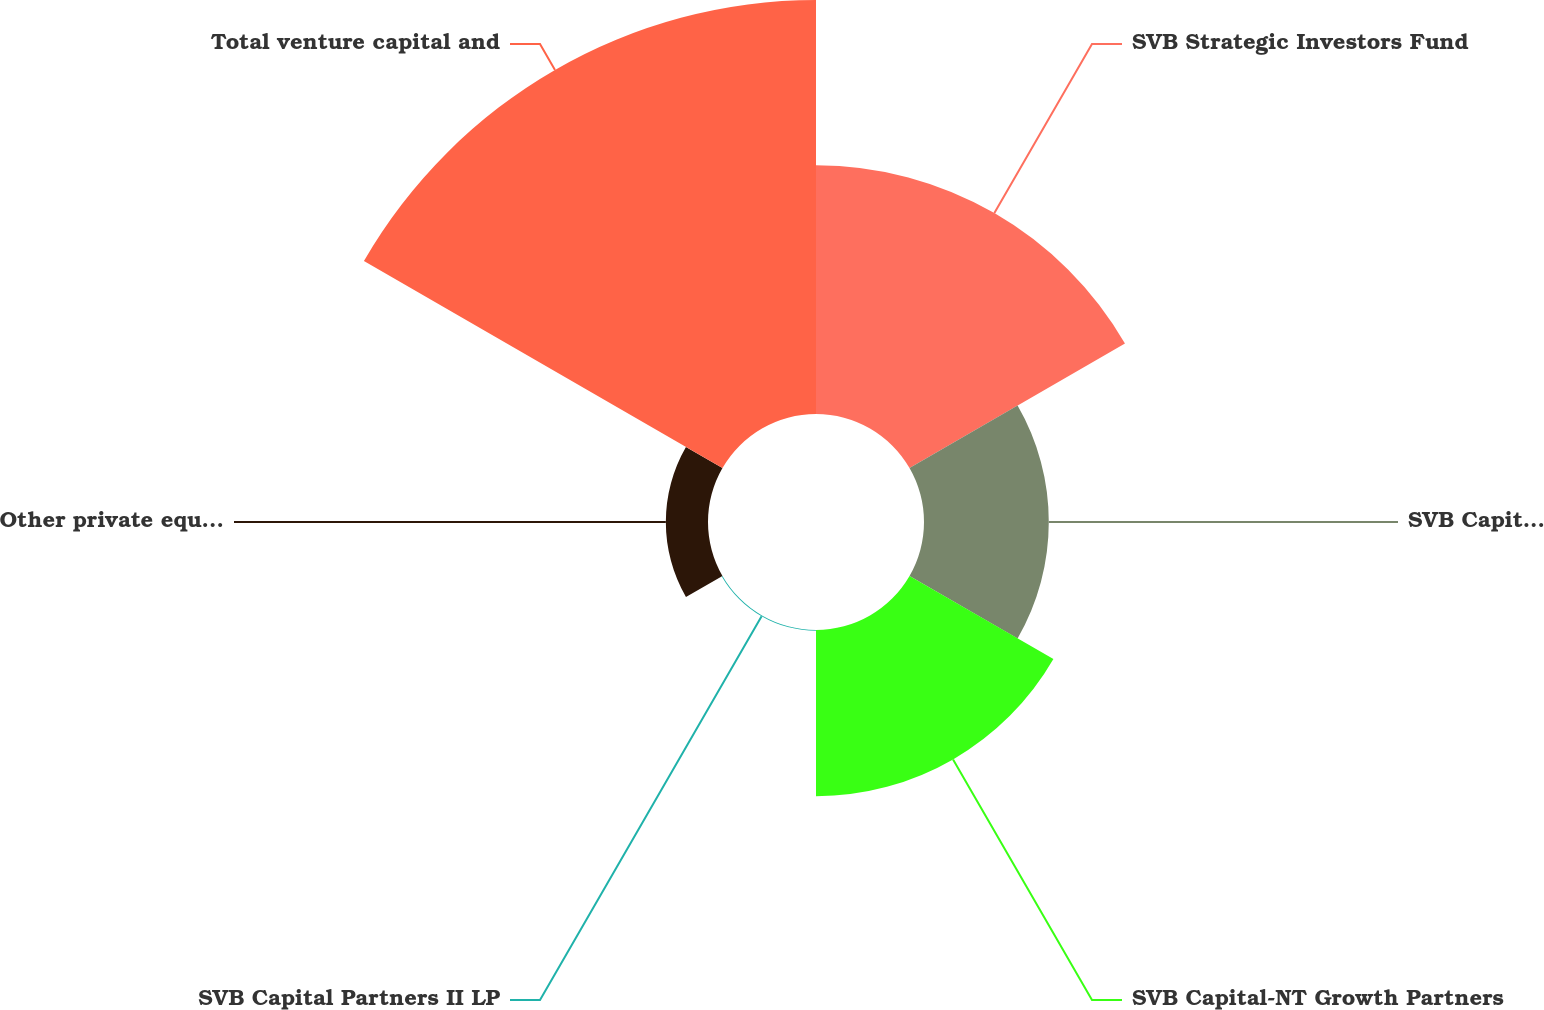<chart> <loc_0><loc_0><loc_500><loc_500><pie_chart><fcel>SVB Strategic Investors Fund<fcel>SVB Capital Preferred Return<fcel>SVB Capital-NT Growth Partners<fcel>SVB Capital Partners II LP<fcel>Other private equity fund<fcel>Total venture capital and<nl><fcel>24.96%<fcel>12.52%<fcel>16.67%<fcel>0.08%<fcel>4.23%<fcel>41.54%<nl></chart> 